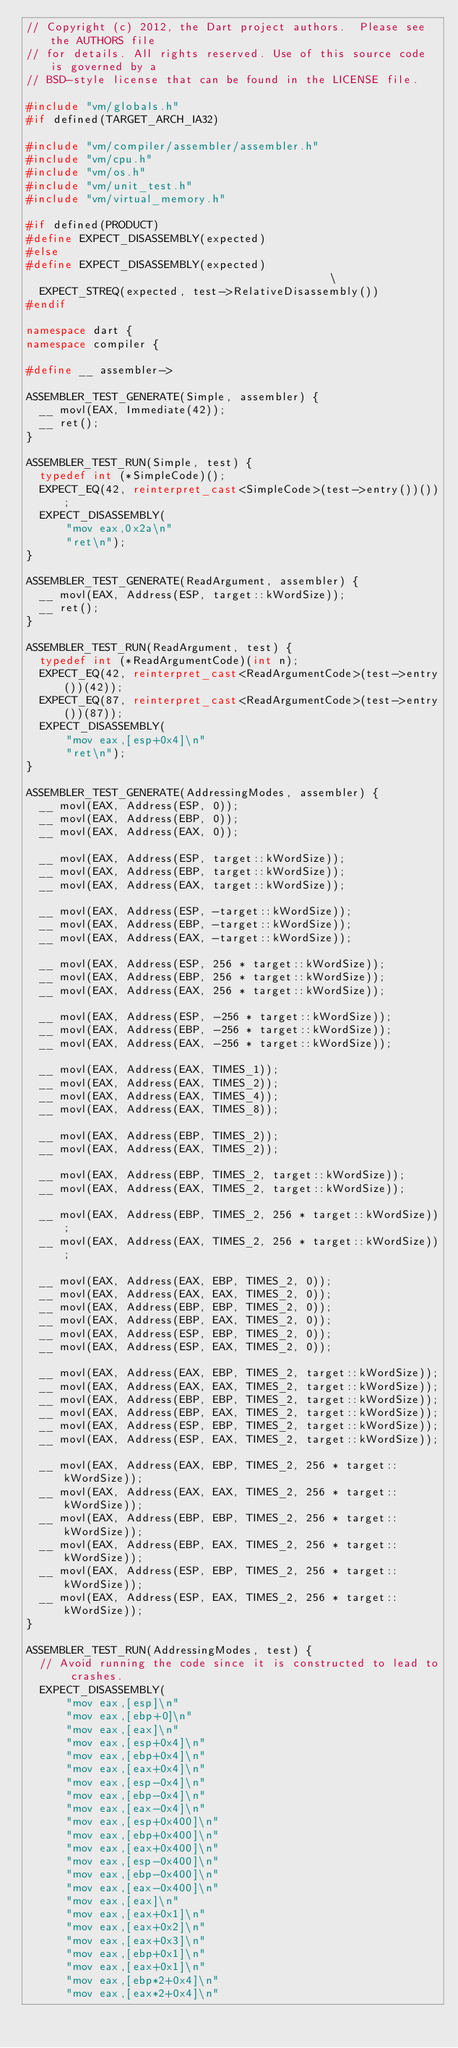<code> <loc_0><loc_0><loc_500><loc_500><_C++_>// Copyright (c) 2012, the Dart project authors.  Please see the AUTHORS file
// for details. All rights reserved. Use of this source code is governed by a
// BSD-style license that can be found in the LICENSE file.

#include "vm/globals.h"
#if defined(TARGET_ARCH_IA32)

#include "vm/compiler/assembler/assembler.h"
#include "vm/cpu.h"
#include "vm/os.h"
#include "vm/unit_test.h"
#include "vm/virtual_memory.h"

#if defined(PRODUCT)
#define EXPECT_DISASSEMBLY(expected)
#else
#define EXPECT_DISASSEMBLY(expected)                                           \
  EXPECT_STREQ(expected, test->RelativeDisassembly())
#endif

namespace dart {
namespace compiler {

#define __ assembler->

ASSEMBLER_TEST_GENERATE(Simple, assembler) {
  __ movl(EAX, Immediate(42));
  __ ret();
}

ASSEMBLER_TEST_RUN(Simple, test) {
  typedef int (*SimpleCode)();
  EXPECT_EQ(42, reinterpret_cast<SimpleCode>(test->entry())());
  EXPECT_DISASSEMBLY(
      "mov eax,0x2a\n"
      "ret\n");
}

ASSEMBLER_TEST_GENERATE(ReadArgument, assembler) {
  __ movl(EAX, Address(ESP, target::kWordSize));
  __ ret();
}

ASSEMBLER_TEST_RUN(ReadArgument, test) {
  typedef int (*ReadArgumentCode)(int n);
  EXPECT_EQ(42, reinterpret_cast<ReadArgumentCode>(test->entry())(42));
  EXPECT_EQ(87, reinterpret_cast<ReadArgumentCode>(test->entry())(87));
  EXPECT_DISASSEMBLY(
      "mov eax,[esp+0x4]\n"
      "ret\n");
}

ASSEMBLER_TEST_GENERATE(AddressingModes, assembler) {
  __ movl(EAX, Address(ESP, 0));
  __ movl(EAX, Address(EBP, 0));
  __ movl(EAX, Address(EAX, 0));

  __ movl(EAX, Address(ESP, target::kWordSize));
  __ movl(EAX, Address(EBP, target::kWordSize));
  __ movl(EAX, Address(EAX, target::kWordSize));

  __ movl(EAX, Address(ESP, -target::kWordSize));
  __ movl(EAX, Address(EBP, -target::kWordSize));
  __ movl(EAX, Address(EAX, -target::kWordSize));

  __ movl(EAX, Address(ESP, 256 * target::kWordSize));
  __ movl(EAX, Address(EBP, 256 * target::kWordSize));
  __ movl(EAX, Address(EAX, 256 * target::kWordSize));

  __ movl(EAX, Address(ESP, -256 * target::kWordSize));
  __ movl(EAX, Address(EBP, -256 * target::kWordSize));
  __ movl(EAX, Address(EAX, -256 * target::kWordSize));

  __ movl(EAX, Address(EAX, TIMES_1));
  __ movl(EAX, Address(EAX, TIMES_2));
  __ movl(EAX, Address(EAX, TIMES_4));
  __ movl(EAX, Address(EAX, TIMES_8));

  __ movl(EAX, Address(EBP, TIMES_2));
  __ movl(EAX, Address(EAX, TIMES_2));

  __ movl(EAX, Address(EBP, TIMES_2, target::kWordSize));
  __ movl(EAX, Address(EAX, TIMES_2, target::kWordSize));

  __ movl(EAX, Address(EBP, TIMES_2, 256 * target::kWordSize));
  __ movl(EAX, Address(EAX, TIMES_2, 256 * target::kWordSize));

  __ movl(EAX, Address(EAX, EBP, TIMES_2, 0));
  __ movl(EAX, Address(EAX, EAX, TIMES_2, 0));
  __ movl(EAX, Address(EBP, EBP, TIMES_2, 0));
  __ movl(EAX, Address(EBP, EAX, TIMES_2, 0));
  __ movl(EAX, Address(ESP, EBP, TIMES_2, 0));
  __ movl(EAX, Address(ESP, EAX, TIMES_2, 0));

  __ movl(EAX, Address(EAX, EBP, TIMES_2, target::kWordSize));
  __ movl(EAX, Address(EAX, EAX, TIMES_2, target::kWordSize));
  __ movl(EAX, Address(EBP, EBP, TIMES_2, target::kWordSize));
  __ movl(EAX, Address(EBP, EAX, TIMES_2, target::kWordSize));
  __ movl(EAX, Address(ESP, EBP, TIMES_2, target::kWordSize));
  __ movl(EAX, Address(ESP, EAX, TIMES_2, target::kWordSize));

  __ movl(EAX, Address(EAX, EBP, TIMES_2, 256 * target::kWordSize));
  __ movl(EAX, Address(EAX, EAX, TIMES_2, 256 * target::kWordSize));
  __ movl(EAX, Address(EBP, EBP, TIMES_2, 256 * target::kWordSize));
  __ movl(EAX, Address(EBP, EAX, TIMES_2, 256 * target::kWordSize));
  __ movl(EAX, Address(ESP, EBP, TIMES_2, 256 * target::kWordSize));
  __ movl(EAX, Address(ESP, EAX, TIMES_2, 256 * target::kWordSize));
}

ASSEMBLER_TEST_RUN(AddressingModes, test) {
  // Avoid running the code since it is constructed to lead to crashes.
  EXPECT_DISASSEMBLY(
      "mov eax,[esp]\n"
      "mov eax,[ebp+0]\n"
      "mov eax,[eax]\n"
      "mov eax,[esp+0x4]\n"
      "mov eax,[ebp+0x4]\n"
      "mov eax,[eax+0x4]\n"
      "mov eax,[esp-0x4]\n"
      "mov eax,[ebp-0x4]\n"
      "mov eax,[eax-0x4]\n"
      "mov eax,[esp+0x400]\n"
      "mov eax,[ebp+0x400]\n"
      "mov eax,[eax+0x400]\n"
      "mov eax,[esp-0x400]\n"
      "mov eax,[ebp-0x400]\n"
      "mov eax,[eax-0x400]\n"
      "mov eax,[eax]\n"
      "mov eax,[eax+0x1]\n"
      "mov eax,[eax+0x2]\n"
      "mov eax,[eax+0x3]\n"
      "mov eax,[ebp+0x1]\n"
      "mov eax,[eax+0x1]\n"
      "mov eax,[ebp*2+0x4]\n"
      "mov eax,[eax*2+0x4]\n"</code> 